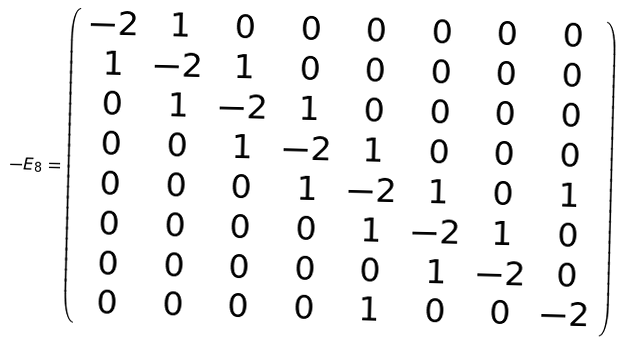Convert formula to latex. <formula><loc_0><loc_0><loc_500><loc_500>- E _ { 8 } = \left ( \begin{array} { c c c c c c c c } - 2 & 1 & 0 & 0 & 0 & 0 & 0 & 0 \\ 1 & - 2 & 1 & 0 & 0 & 0 & 0 & 0 \\ 0 & 1 & - 2 & 1 & 0 & 0 & 0 & 0 \\ 0 & 0 & 1 & - 2 & 1 & 0 & 0 & 0 \\ 0 & 0 & 0 & 1 & - 2 & 1 & 0 & 1 \\ 0 & 0 & 0 & 0 & 1 & - 2 & 1 & 0 \\ 0 & 0 & 0 & 0 & 0 & 1 & - 2 & 0 \\ 0 & 0 & 0 & 0 & 1 & 0 & 0 & - 2 \end{array} \right )</formula> 